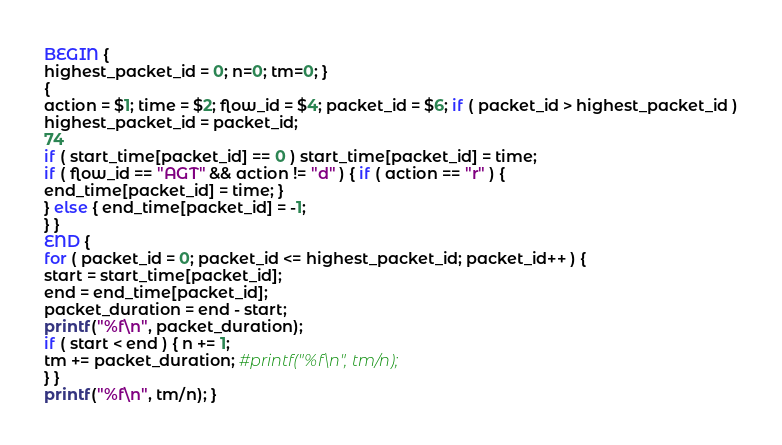<code> <loc_0><loc_0><loc_500><loc_500><_Awk_>BEGIN {
highest_packet_id = 0; n=0; tm=0; }
{
action = $1; time = $2; flow_id = $4; packet_id = $6; if ( packet_id > highest_packet_id )
highest_packet_id = packet_id;
74
if ( start_time[packet_id] == 0 ) start_time[packet_id] = time;
if ( flow_id == "AGT" && action != "d" ) { if ( action == "r" ) {
end_time[packet_id] = time; }
} else { end_time[packet_id] = -1;
} }
END {
for ( packet_id = 0; packet_id <= highest_packet_id; packet_id++ ) {
start = start_time[packet_id];
end = end_time[packet_id]; 
packet_duration = end - start;
printf("%f\n", packet_duration);
if ( start < end ) { n += 1;
tm += packet_duration; #printf("%f\n", tm/n);
} }
printf("%f\n", tm/n); }
</code> 